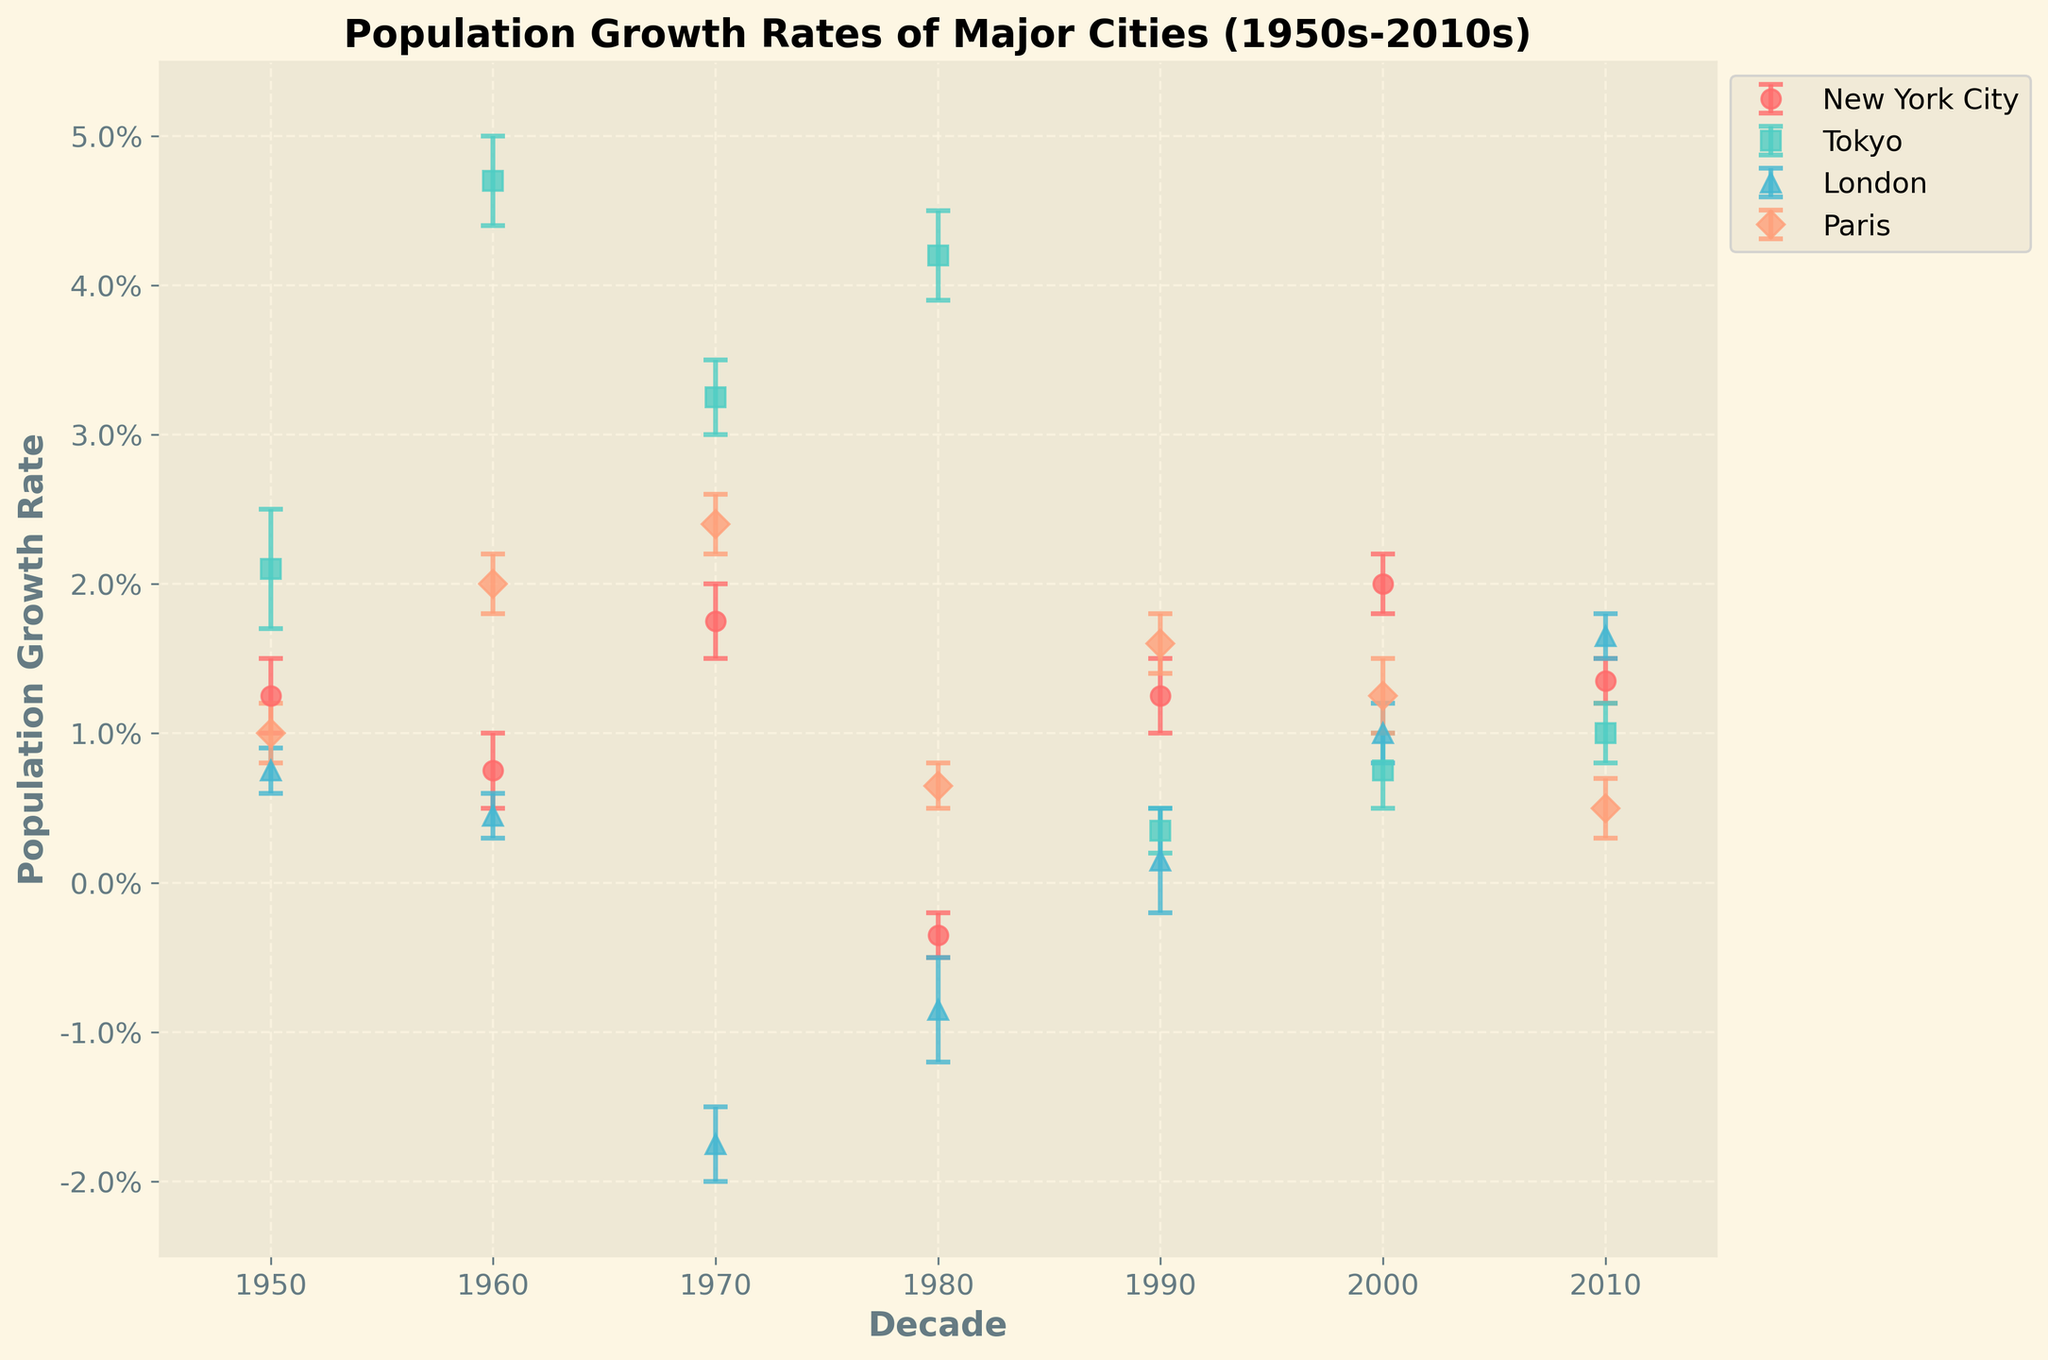What is the overall trend in population growth for New York City from the 1950s to the 2010s? By analyzing the plot, New York City shows fluctuations in its population growth rate. It peaks in the 1970s, drops in the 1980s, and then generally increases again but with varying growth rates.
Answer: Fluctuating trend How does Tokyo's population growth in the 1950s compare to its growth in the 2010s? To compare Tokyo's growth, look at the growth rate values for the 1950s and 2010s. In the 1950s, it's around a higher range (0.017 to 0.025), while in the 2010s, it's lower (0.008 to 0.012).
Answer: Higher in the 1950s What decade saw the highest growth rate for Paris, and what was the approximate value of that growth rate? Identify the decade with the largest value in the y-axis for Paris. The 1970s had the highest growth rate of approximately 2.4%.
Answer: 1970s, ~2.4% Which city experienced negative growth in any of its decades, and which decade was it? Look for any line segments with downward trends and corresponding negative growth values. London experienced negative growth in the 1970s and 1980s.
Answer: London, 1970s and 1980s What are the population growth rates for London in the 2010s? Find the data points for London in the 2010s on the graph. The growth rate for London in this period is around 0.015-0.018.
Answer: ~1.5% to ~1.8% Compare the growth rate of New York City in the 2000s with that of Tokyo in the same period. Examine both growth rates in the 2000s. New York City's growth rate is higher (0.018 to 0.022) compared to Tokyo's (0.005 to 0.010).
Answer: Higher in New York City In which decade did New York City have its lowest population growth rate, and what was the value? Identify the lowest point on New York City's growth rate line. The lowest value is in the 1980s, with negative growth rates between -0.005 and -0.002.
Answer: 1980s, ~-0.35% What trend can be observed in the population growth rate of London from the 1950s to the 2010s? Analyze the growth rate plot for London across decades. London shows an initial decline, reaching a trough in the 1970s and 1980s, then it stabilizes and rises again from the 1990s onward.
Answer: Decline, stabilize, then increase How does the population growth trend of Paris differ from that of New York City over the decades? Compare the overall shapes and trends of the growth rate lines for Paris and New York City. Paris has a more consistent and steadier growth rate, while New York City's growth is more fluctuated.
Answer: Paris is steadier, New York City fluctuates What decade saw the sharpest increase in growth rate for Tokyo? Identify the decade with the steepest upward slope for Tokyo. The sharpest increase is seen in the 1960s.
Answer: 1960s 